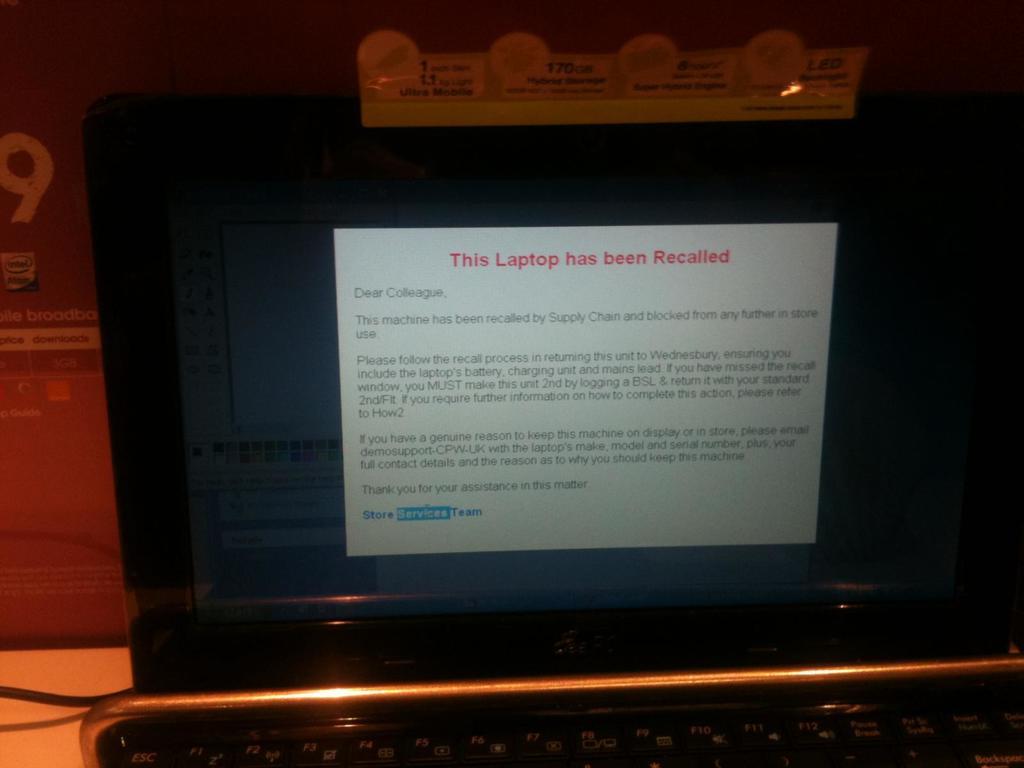Red warning at the top?
Provide a succinct answer. This laptop has been recalled. Who is the letter addressed from?
Your answer should be very brief. Store services team. 